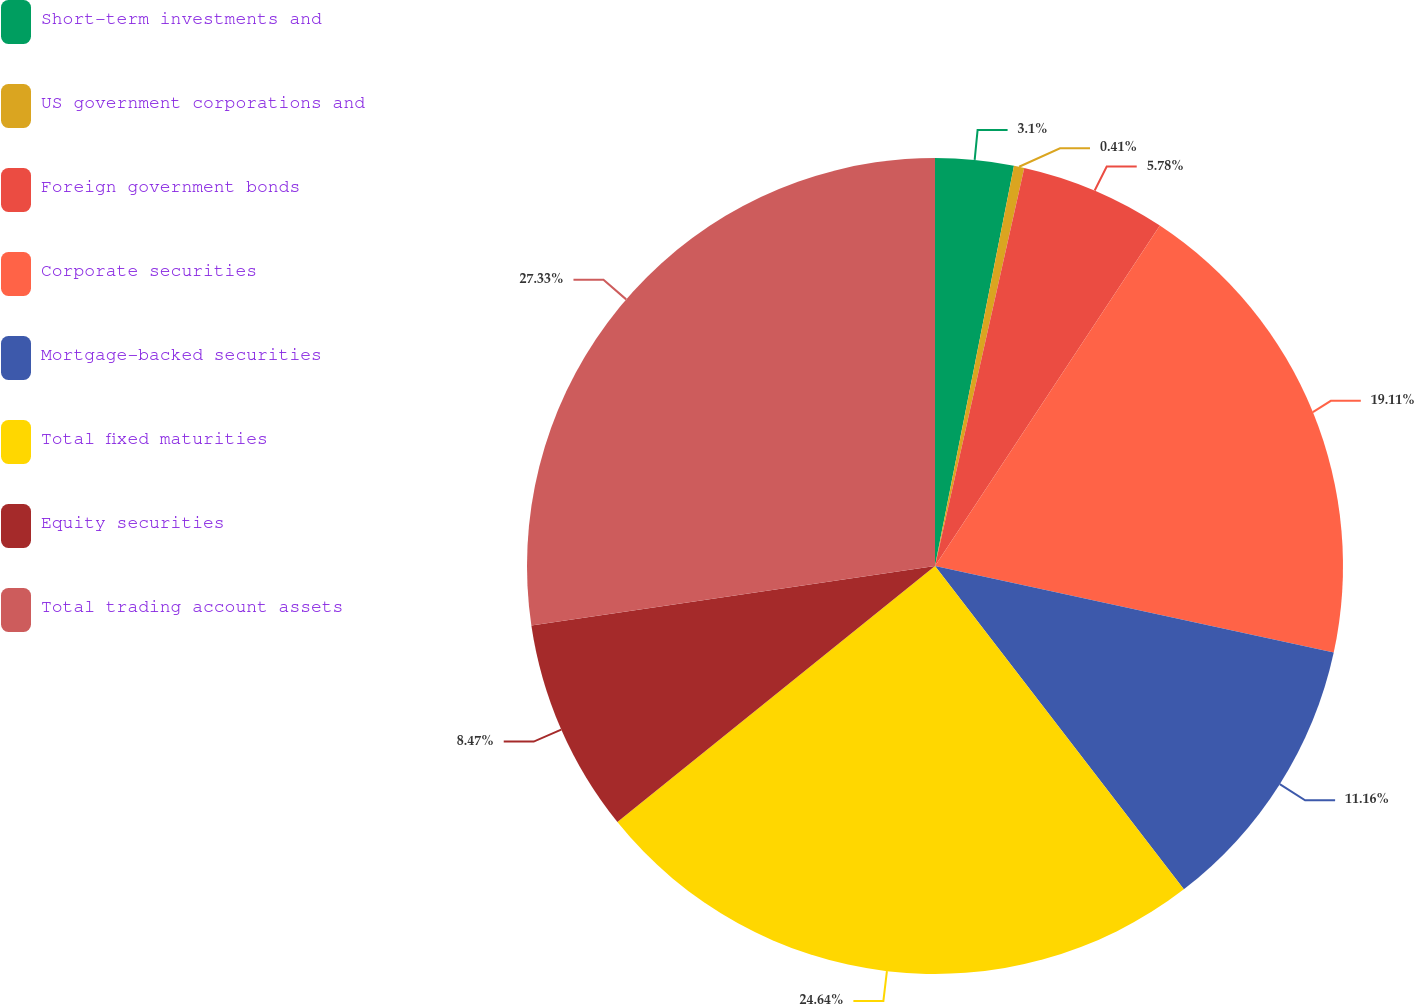Convert chart. <chart><loc_0><loc_0><loc_500><loc_500><pie_chart><fcel>Short-term investments and<fcel>US government corporations and<fcel>Foreign government bonds<fcel>Corporate securities<fcel>Mortgage-backed securities<fcel>Total fixed maturities<fcel>Equity securities<fcel>Total trading account assets<nl><fcel>3.1%<fcel>0.41%<fcel>5.78%<fcel>19.11%<fcel>11.16%<fcel>24.64%<fcel>8.47%<fcel>27.33%<nl></chart> 